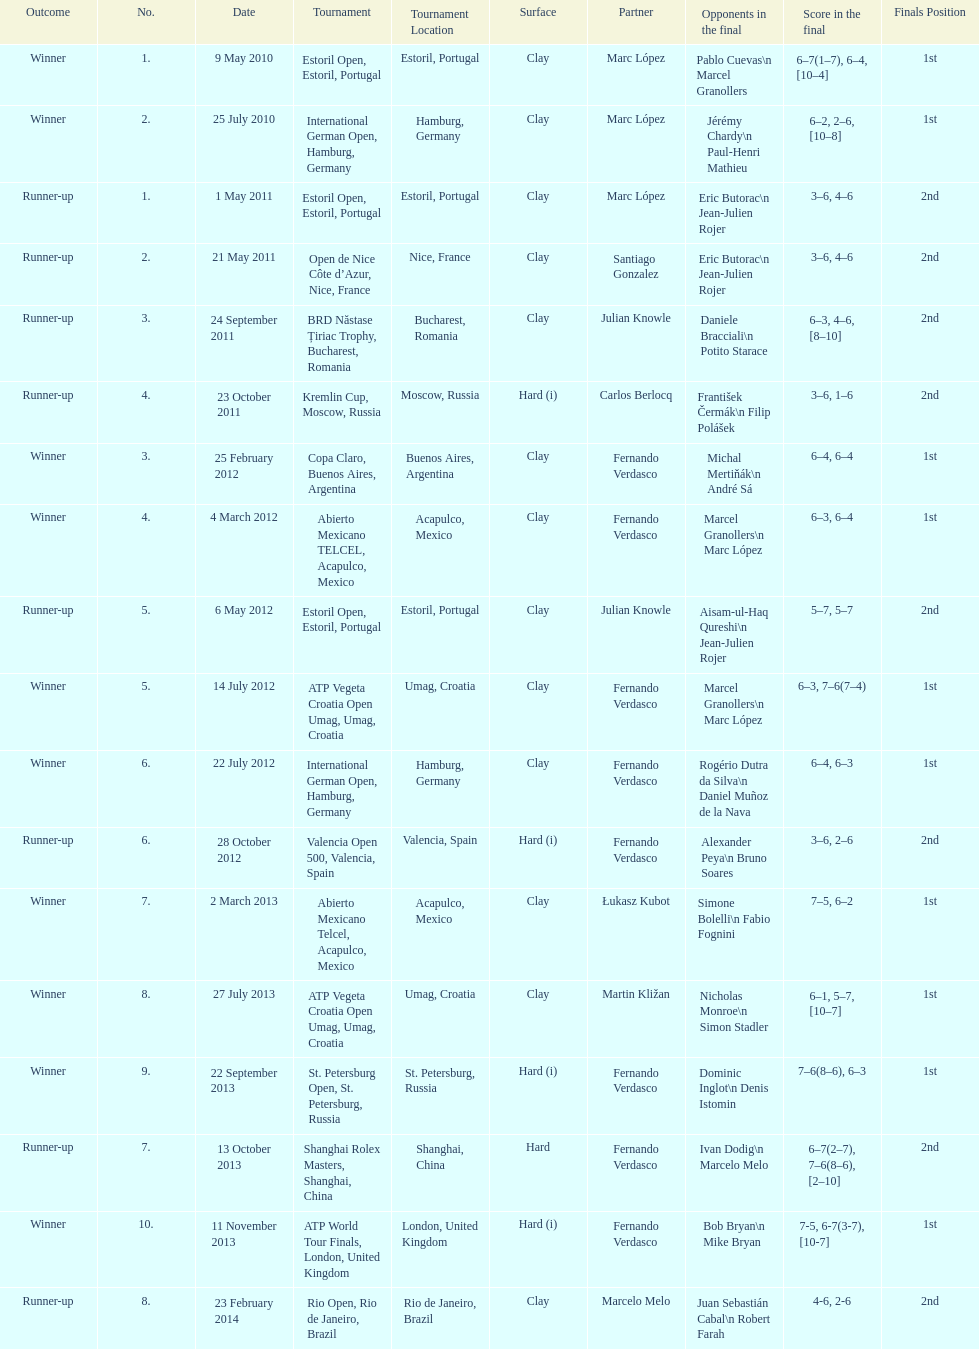What tournament was played after the kremlin cup? Copa Claro, Buenos Aires, Argentina. 